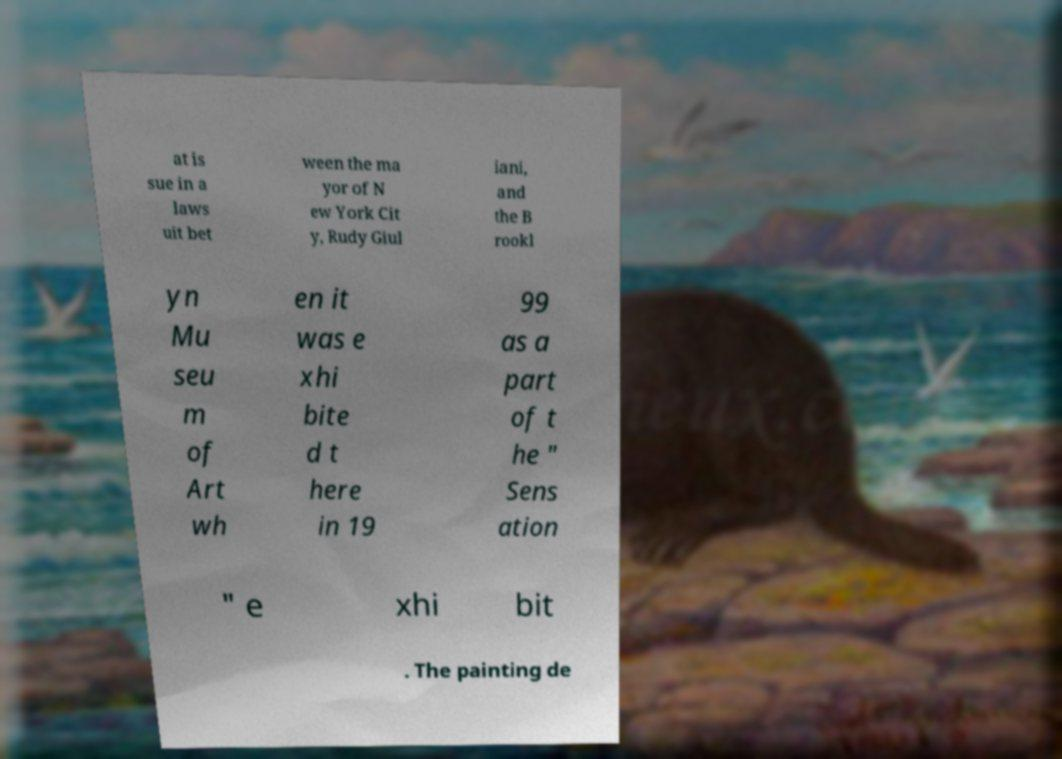Can you read and provide the text displayed in the image?This photo seems to have some interesting text. Can you extract and type it out for me? at is sue in a laws uit bet ween the ma yor of N ew York Cit y, Rudy Giul iani, and the B rookl yn Mu seu m of Art wh en it was e xhi bite d t here in 19 99 as a part of t he " Sens ation " e xhi bit . The painting de 